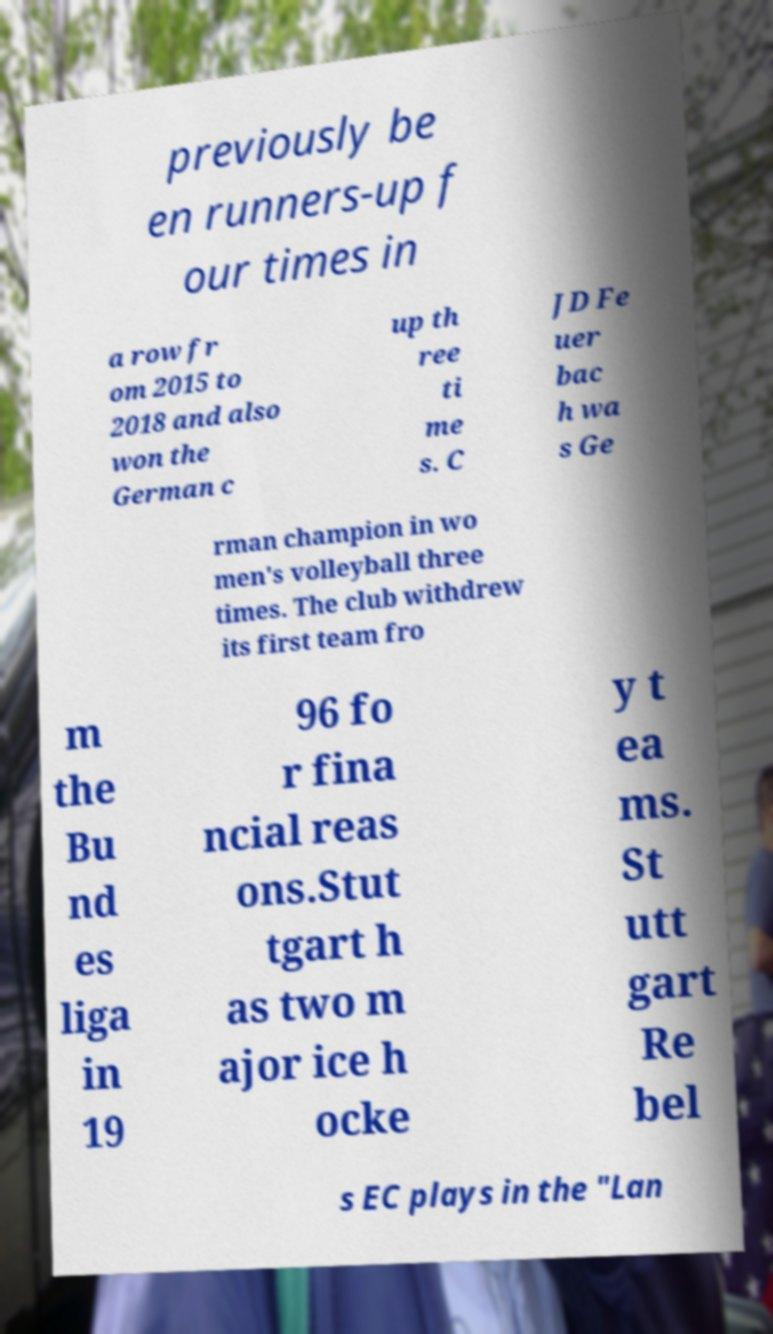Please identify and transcribe the text found in this image. previously be en runners-up f our times in a row fr om 2015 to 2018 and also won the German c up th ree ti me s. C JD Fe uer bac h wa s Ge rman champion in wo men's volleyball three times. The club withdrew its first team fro m the Bu nd es liga in 19 96 fo r fina ncial reas ons.Stut tgart h as two m ajor ice h ocke y t ea ms. St utt gart Re bel s EC plays in the "Lan 